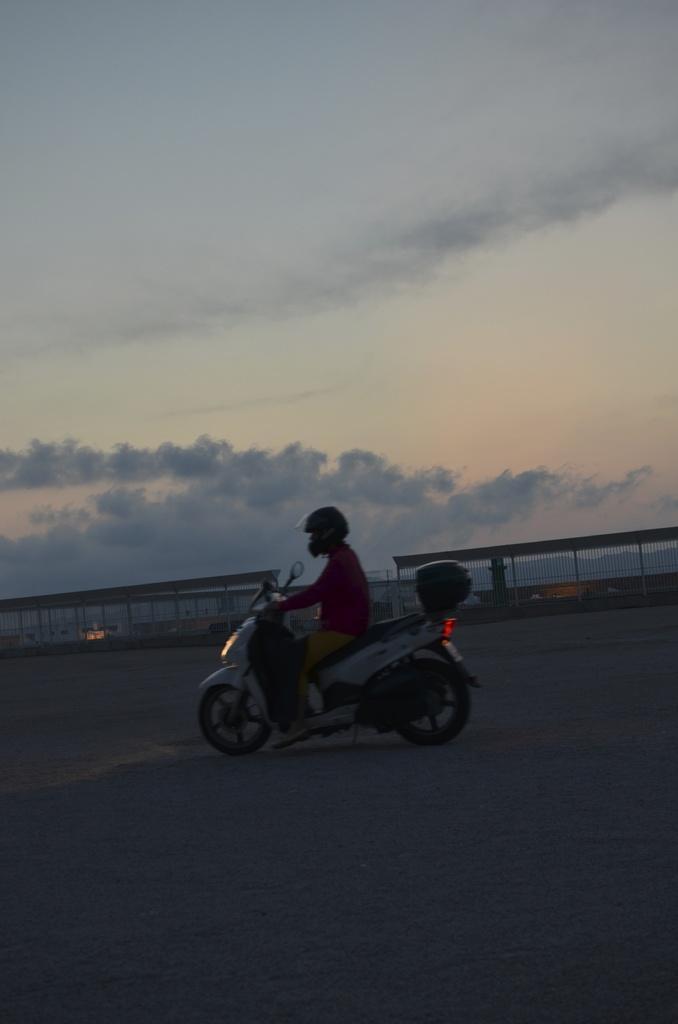How would you summarize this image in a sentence or two? In this picture we can see a man wearing red color t-shirt and brown pant riding scooter on the road. Behind we can see fencing railing and above we can see clear blue sky. 